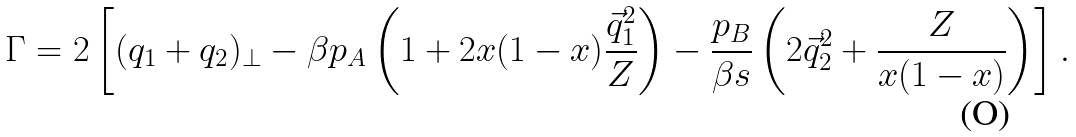<formula> <loc_0><loc_0><loc_500><loc_500>\Gamma = 2 \left [ ( q _ { 1 } + q _ { 2 } ) _ { \perp } - \beta p _ { A } \left ( 1 + 2 x ( 1 - x ) \frac { \vec { q } _ { 1 } ^ { 2 } } Z \right ) - \frac { p _ { B } } { \beta s } \left ( 2 \vec { q } _ { 2 } ^ { 2 } + \frac { Z } { x ( 1 - x ) } \right ) \right ] .</formula> 